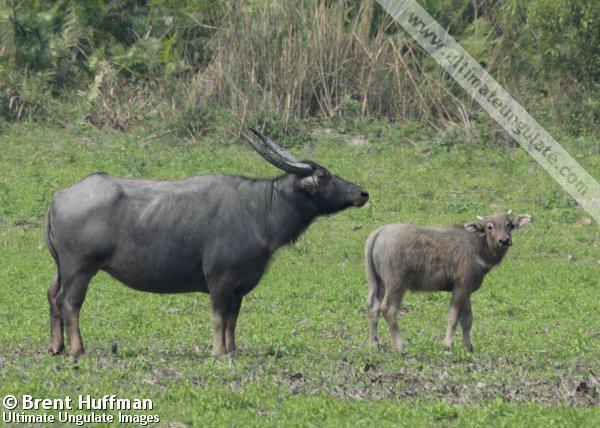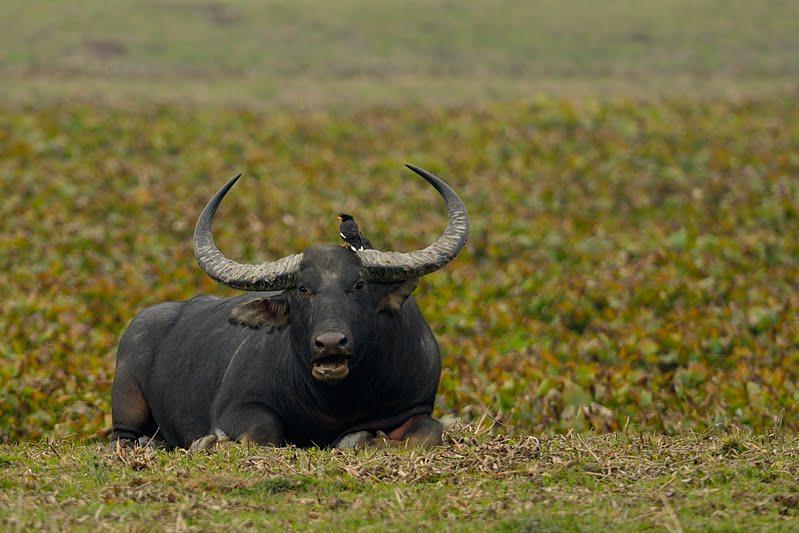The first image is the image on the left, the second image is the image on the right. Examine the images to the left and right. Is the description "There are exactly two water buffalos with one of them facing leftward." accurate? Answer yes or no. No. The first image is the image on the left, the second image is the image on the right. For the images displayed, is the sentence "In at least one image,there is a single black bull with two long horns facing left on grass and dirt." factually correct? Answer yes or no. No. 